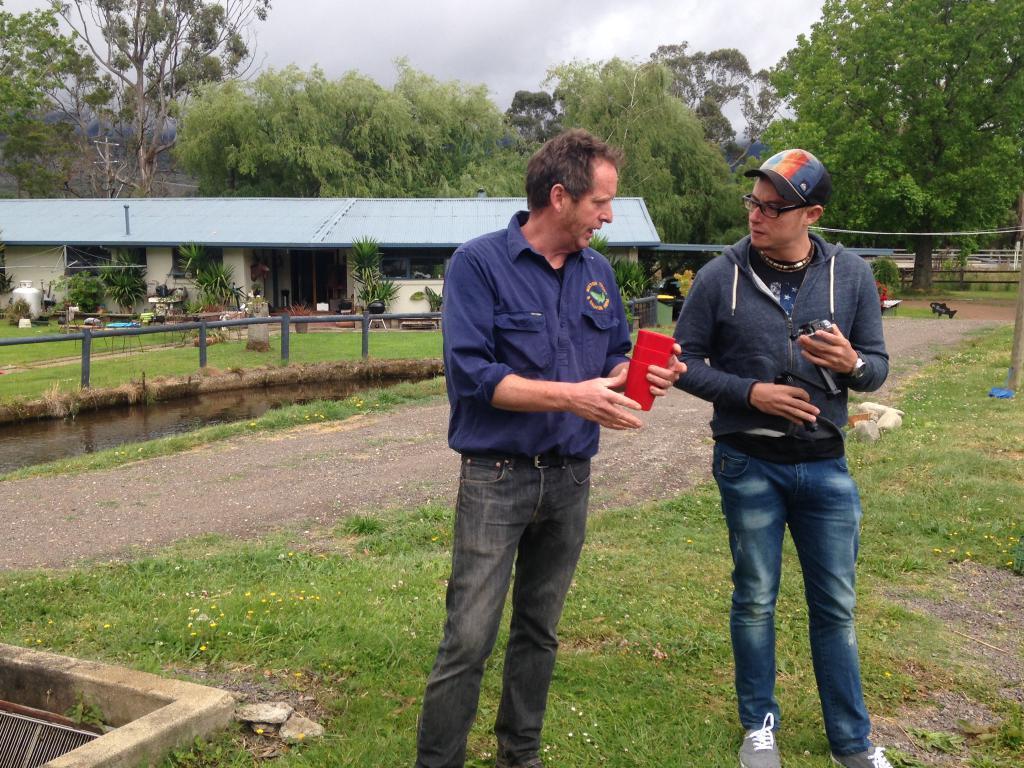In one or two sentences, can you explain what this image depicts? In this image we can able to see two persons standing and holding some objects in their hands, behind them there is a house, a car, some house plants, also we can see some stones, grass, trees, fence, beside fence we can see water, there is an electric pole, we can see the sky. 